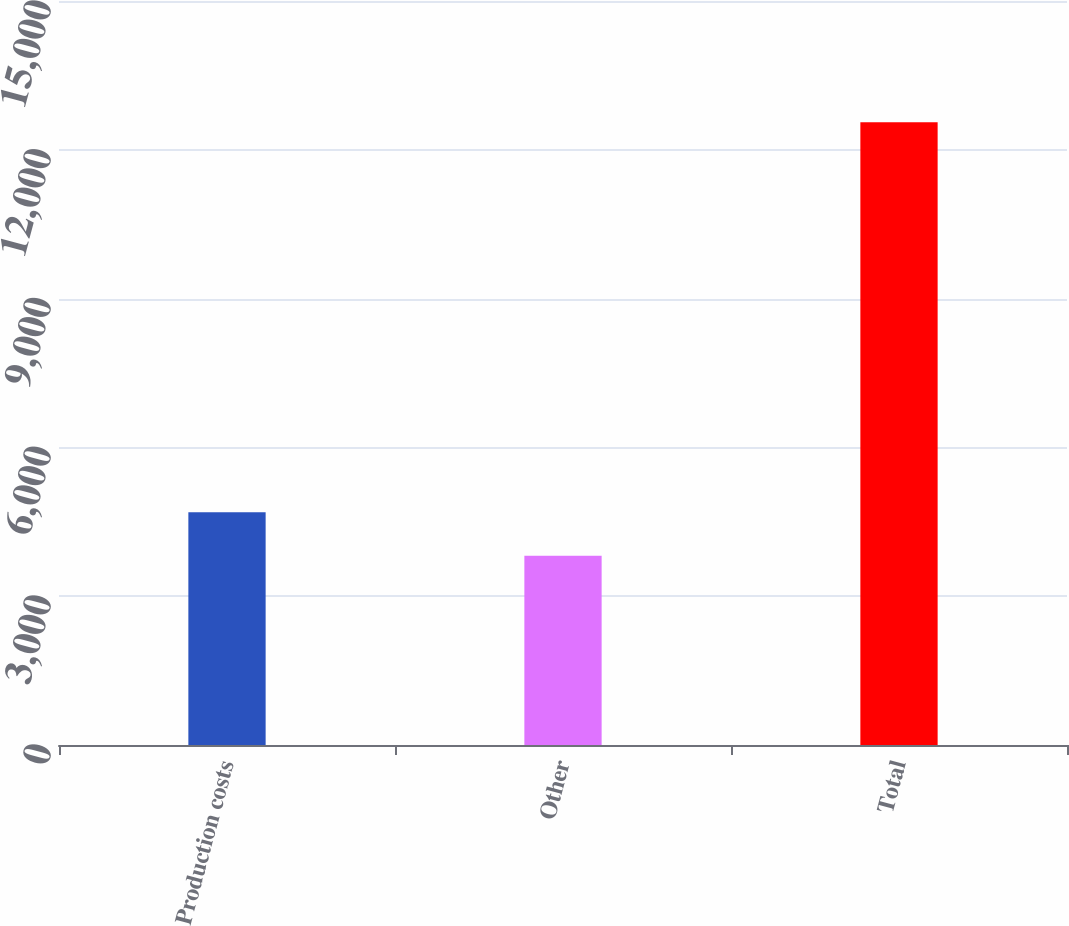Convert chart to OTSL. <chart><loc_0><loc_0><loc_500><loc_500><bar_chart><fcel>Production costs<fcel>Other<fcel>Total<nl><fcel>4691.8<fcel>3818<fcel>12556<nl></chart> 